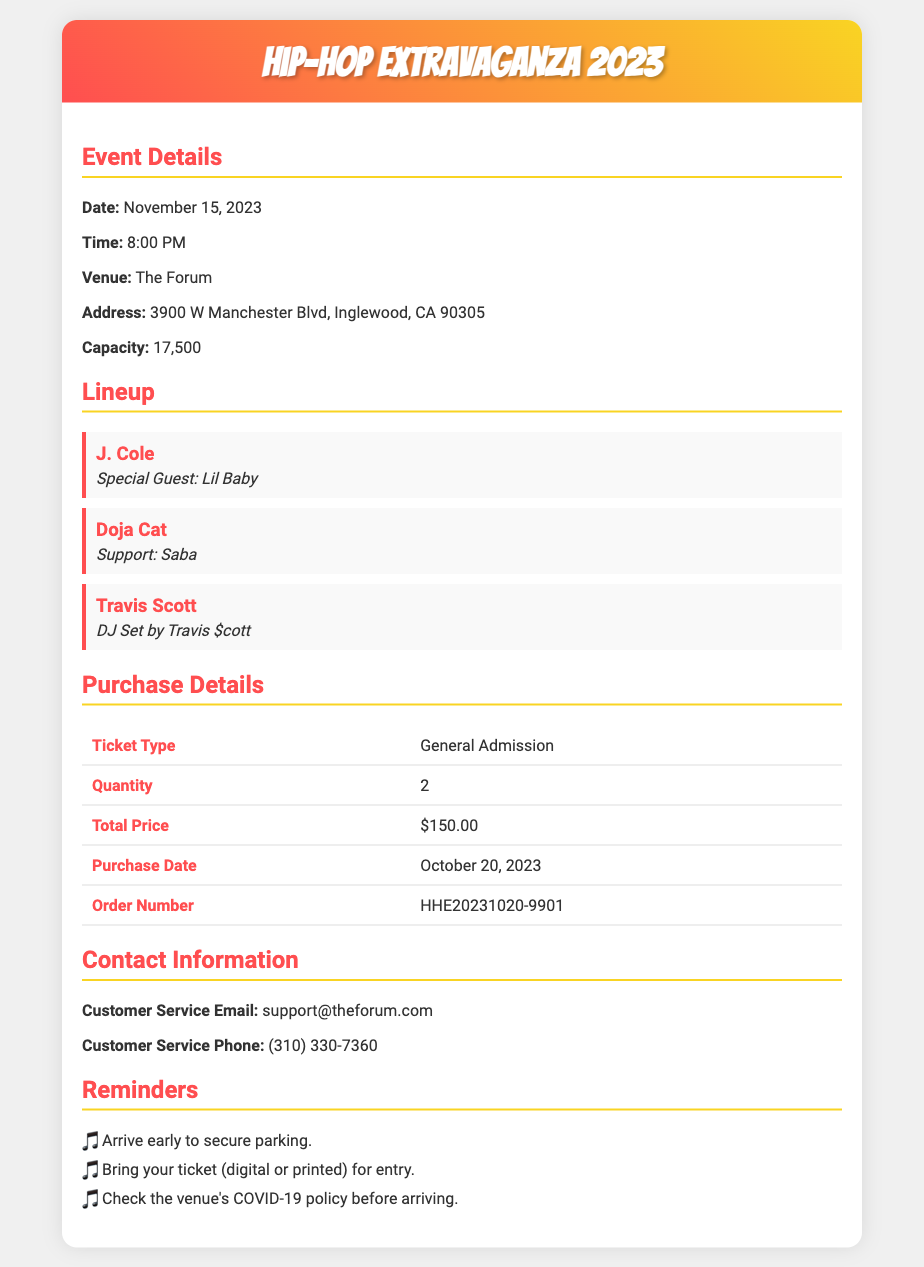What is the date of the concert? The date of the concert is stated in the event details section.
Answer: November 15, 2023 Who is the special guest for J. Cole? The special guest for J. Cole is mentioned in the lineup section.
Answer: Lil Baby What is the total price of the tickets? The total price is found in the purchase details table of the document.
Answer: $150.00 What is the venue's capacity? The venue's capacity is included in the event details.
Answer: 17,500 What type of tickets did I purchase? The ticket type is listed in the purchase details section of the document.
Answer: General Admission How many tickets did I buy? The quantity of tickets is specified in the purchase details table.
Answer: 2 What time does the concert start? The start time of the concert is mentioned in the event details section.
Answer: 8:00 PM What is the order number for my purchase? The order number is included in the purchase details table.
Answer: HHE20231020-9901 What should I bring for entry? The reminders section specifies what to bring for entry.
Answer: Your ticket (digital or printed) 